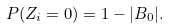Convert formula to latex. <formula><loc_0><loc_0><loc_500><loc_500>P ( Z _ { i } = 0 ) = 1 - | B _ { 0 } | .</formula> 